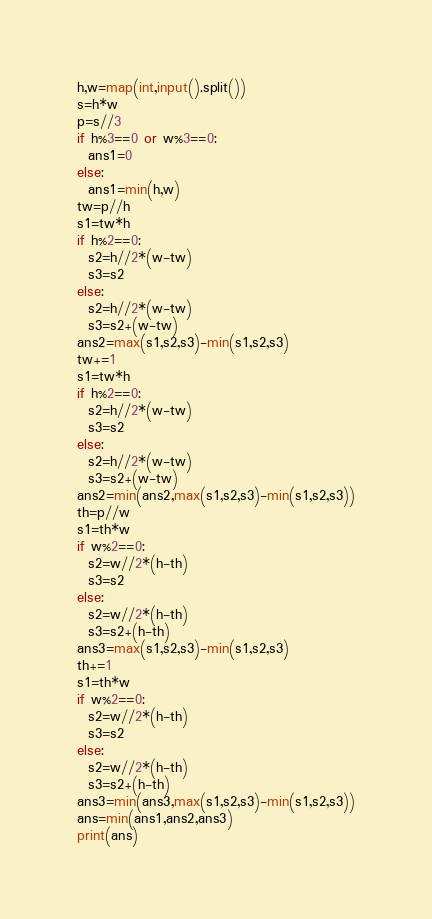Convert code to text. <code><loc_0><loc_0><loc_500><loc_500><_Python_>h,w=map(int,input().split())
s=h*w
p=s//3
if h%3==0 or w%3==0:
  ans1=0
else:
  ans1=min(h,w)
tw=p//h
s1=tw*h
if h%2==0:
  s2=h//2*(w-tw)
  s3=s2
else:
  s2=h//2*(w-tw)
  s3=s2+(w-tw)
ans2=max(s1,s2,s3)-min(s1,s2,s3)
tw+=1
s1=tw*h
if h%2==0:
  s2=h//2*(w-tw)
  s3=s2
else:
  s2=h//2*(w-tw)
  s3=s2+(w-tw)
ans2=min(ans2,max(s1,s2,s3)-min(s1,s2,s3))
th=p//w
s1=th*w
if w%2==0:
  s2=w//2*(h-th)
  s3=s2
else:
  s2=w//2*(h-th)
  s3=s2+(h-th)
ans3=max(s1,s2,s3)-min(s1,s2,s3)
th+=1
s1=th*w
if w%2==0:
  s2=w//2*(h-th)
  s3=s2
else:
  s2=w//2*(h-th)
  s3=s2+(h-th)
ans3=min(ans3,max(s1,s2,s3)-min(s1,s2,s3))
ans=min(ans1,ans2,ans3)
print(ans)</code> 